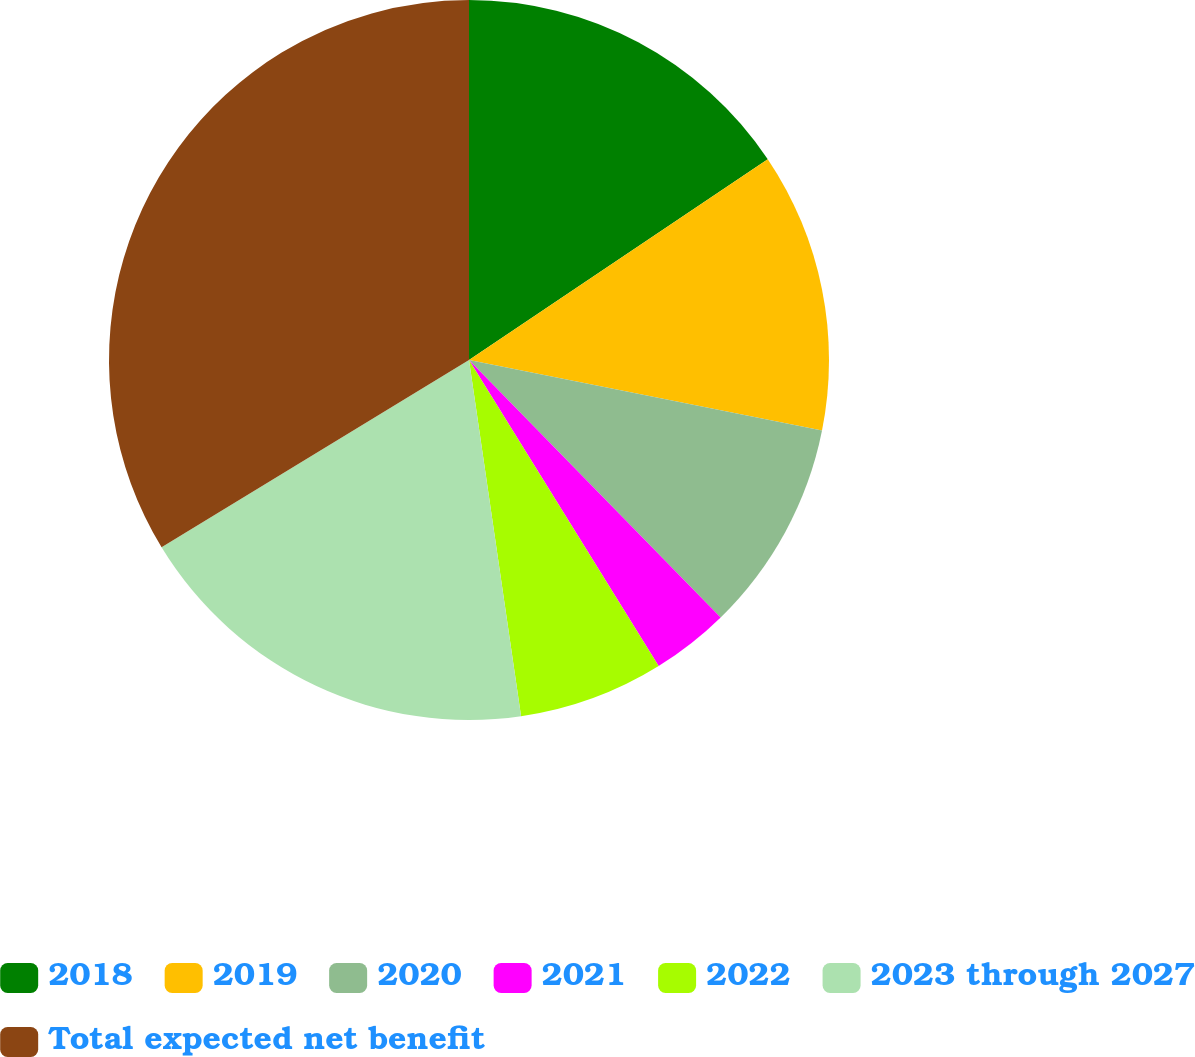Convert chart. <chart><loc_0><loc_0><loc_500><loc_500><pie_chart><fcel>2018<fcel>2019<fcel>2020<fcel>2021<fcel>2022<fcel>2023 through 2027<fcel>Total expected net benefit<nl><fcel>15.58%<fcel>12.56%<fcel>9.54%<fcel>3.49%<fcel>6.52%<fcel>18.6%<fcel>33.71%<nl></chart> 